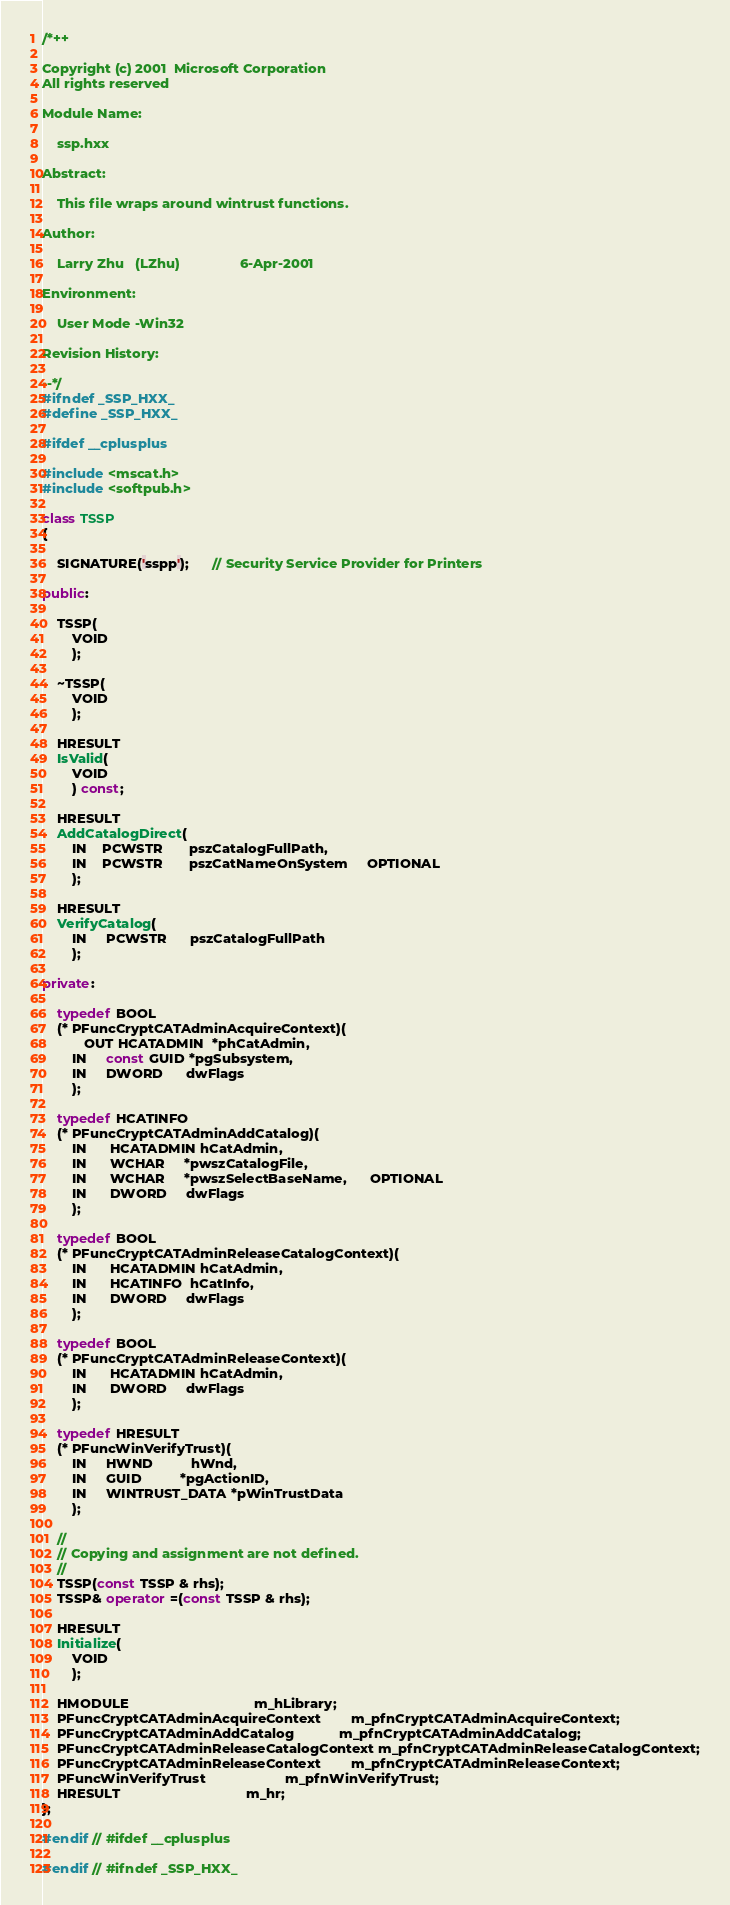Convert code to text. <code><loc_0><loc_0><loc_500><loc_500><_C++_>/*++

Copyright (c) 2001  Microsoft Corporation
All rights reserved

Module Name:

    ssp.hxx

Abstract:

    This file wraps around wintrust functions.

Author:

    Larry Zhu   (LZhu)                6-Apr-2001

Environment:

    User Mode -Win32

Revision History:

--*/
#ifndef _SSP_HXX_
#define _SSP_HXX_

#ifdef __cplusplus

#include <mscat.h>
#include <softpub.h>

class TSSP
{

    SIGNATURE('sspp');      // Security Service Provider for Printers

public:

    TSSP(
        VOID
        );

    ~TSSP(
        VOID
        );

    HRESULT
    IsValid(
        VOID
        ) const;
    
    HRESULT
    AddCatalogDirect(
        IN    PCWSTR       pszCatalogFullPath,
        IN    PCWSTR       pszCatNameOnSystem     OPTIONAL
        );

    HRESULT
    VerifyCatalog(
        IN     PCWSTR      pszCatalogFullPath
        );

private:

    typedef BOOL
    (* PFuncCryptCATAdminAcquireContext)(
           OUT HCATADMIN  *phCatAdmin, 
        IN     const GUID *pgSubsystem, 
        IN     DWORD      dwFlags
        );

    typedef HCATINFO
    (* PFuncCryptCATAdminAddCatalog)(
        IN      HCATADMIN hCatAdmin, 
        IN      WCHAR     *pwszCatalogFile,
        IN      WCHAR     *pwszSelectBaseName,      OPTIONAL 
        IN      DWORD     dwFlags
        );

    typedef BOOL
    (* PFuncCryptCATAdminReleaseCatalogContext)(
        IN      HCATADMIN hCatAdmin,
        IN      HCATINFO  hCatInfo,
        IN      DWORD     dwFlags
        );

    typedef BOOL
    (* PFuncCryptCATAdminReleaseContext)(
        IN      HCATADMIN hCatAdmin,
        IN      DWORD     dwFlags
        );

    typedef HRESULT  
    (* PFuncWinVerifyTrust)(
        IN     HWND          hWnd, 
        IN     GUID          *pgActionID, 
        IN     WINTRUST_DATA *pWinTrustData 
        );

    //
    // Copying and assignment are not defined.
    // 
    TSSP(const TSSP & rhs);
    TSSP& operator =(const TSSP & rhs);

    HRESULT
    Initialize(
        VOID
        );

    HMODULE                                 m_hLibrary;
    PFuncCryptCATAdminAcquireContext        m_pfnCryptCATAdminAcquireContext;
    PFuncCryptCATAdminAddCatalog            m_pfnCryptCATAdminAddCatalog;
    PFuncCryptCATAdminReleaseCatalogContext m_pfnCryptCATAdminReleaseCatalogContext;
    PFuncCryptCATAdminReleaseContext        m_pfnCryptCATAdminReleaseContext;
    PFuncWinVerifyTrust                     m_pfnWinVerifyTrust;
    HRESULT                                 m_hr;
};

#endif // #ifdef __cplusplus

#endif // #ifndef _SSP_HXX_
</code> 